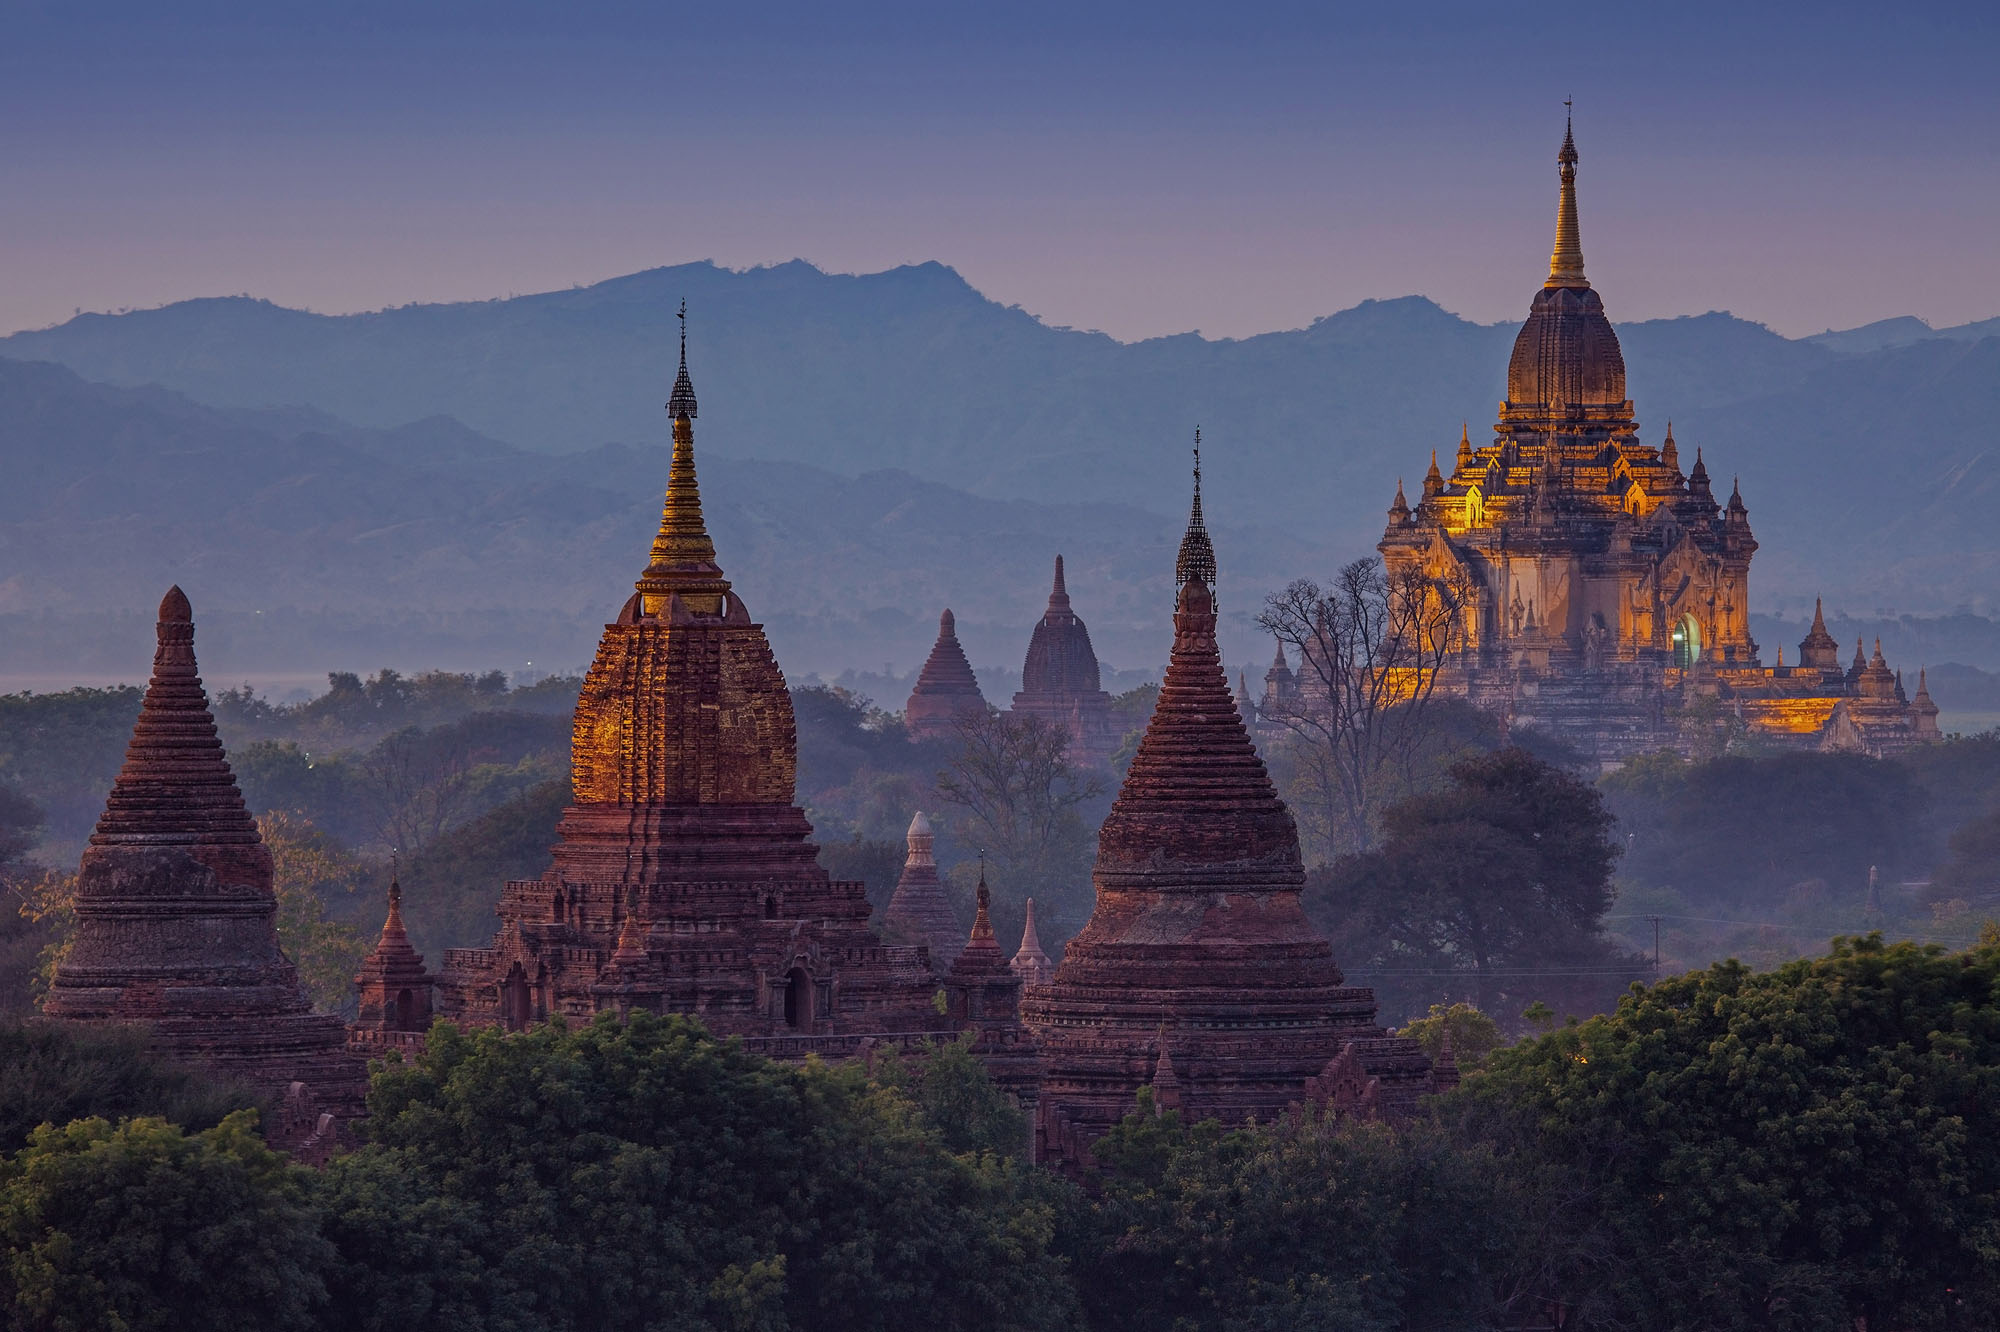What do you think is going on in this snapshot? This image captures the serene and historic panorama of Bagan, Myanmar, home to over 2,000 temples and pagodas dating back to the 9th-13th centuries. As the sun sets, its rays bathe the ancient architecture in golden hues against the distant mountains, adding a mystical quality. This scene is more than just a visual spectacle; it embodies the spiritual and cultural heart of Myanmar, reflecting centuries of religious devotion and architectural dedication. 